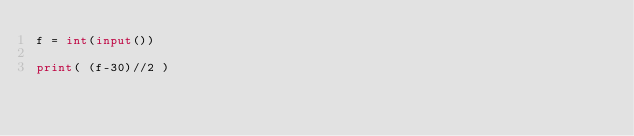Convert code to text. <code><loc_0><loc_0><loc_500><loc_500><_Python_>f = int(input())

print( (f-30)//2 )
</code> 